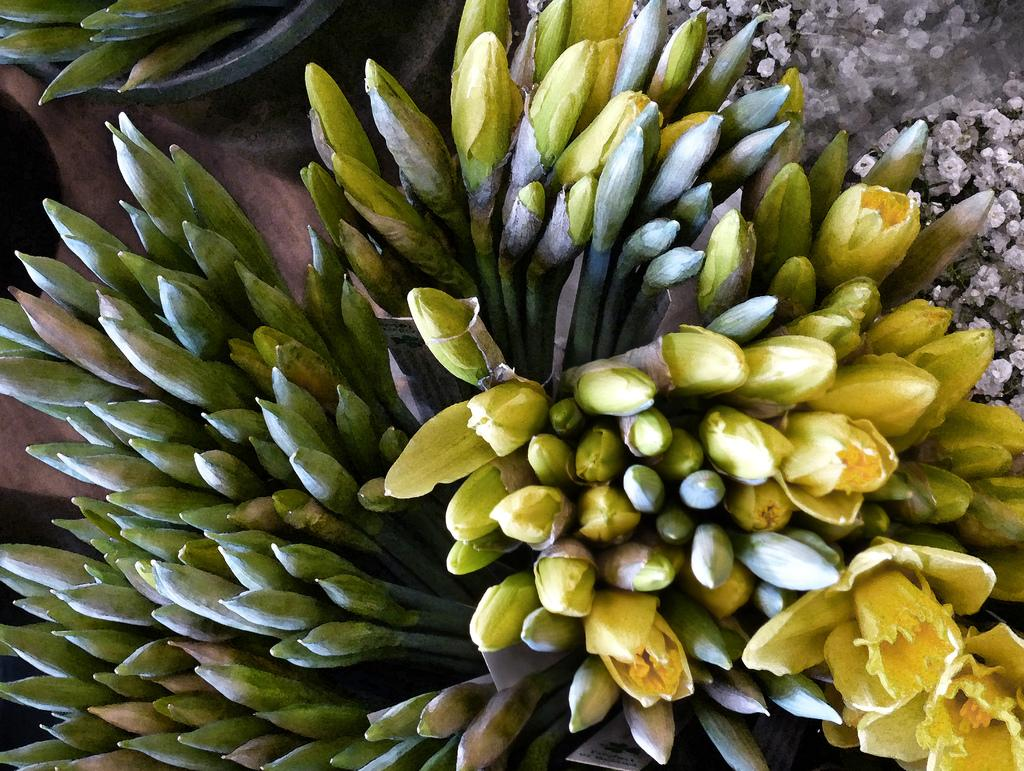What type of plant life can be seen in the image? There are some buds in the image. Where is the flower located in the image? There is a flower in the bottom right of the image. What is the chance of winning the lottery in the image? There is no reference to a lottery or any chances of winning in the image, so it's not possible to determine the odds of winning. 